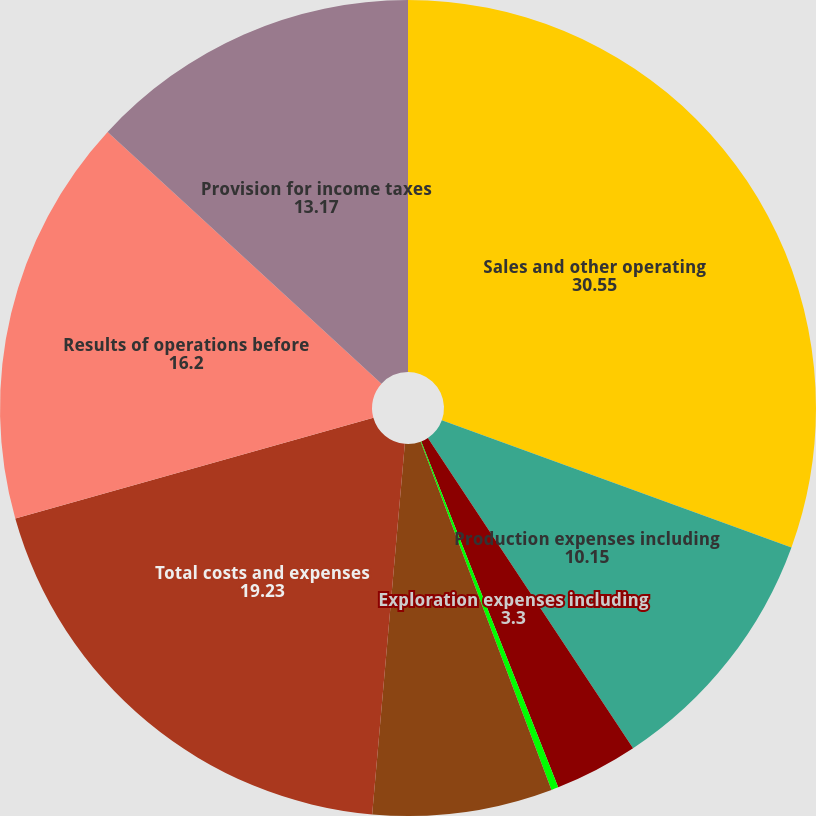Convert chart to OTSL. <chart><loc_0><loc_0><loc_500><loc_500><pie_chart><fcel>Sales and other operating<fcel>Production expenses including<fcel>Exploration expenses including<fcel>General administrative and<fcel>Depreciation depletion and<fcel>Total costs and expenses<fcel>Results of operations before<fcel>Provision for income taxes<nl><fcel>30.55%<fcel>10.15%<fcel>3.3%<fcel>0.28%<fcel>7.12%<fcel>19.23%<fcel>16.2%<fcel>13.17%<nl></chart> 